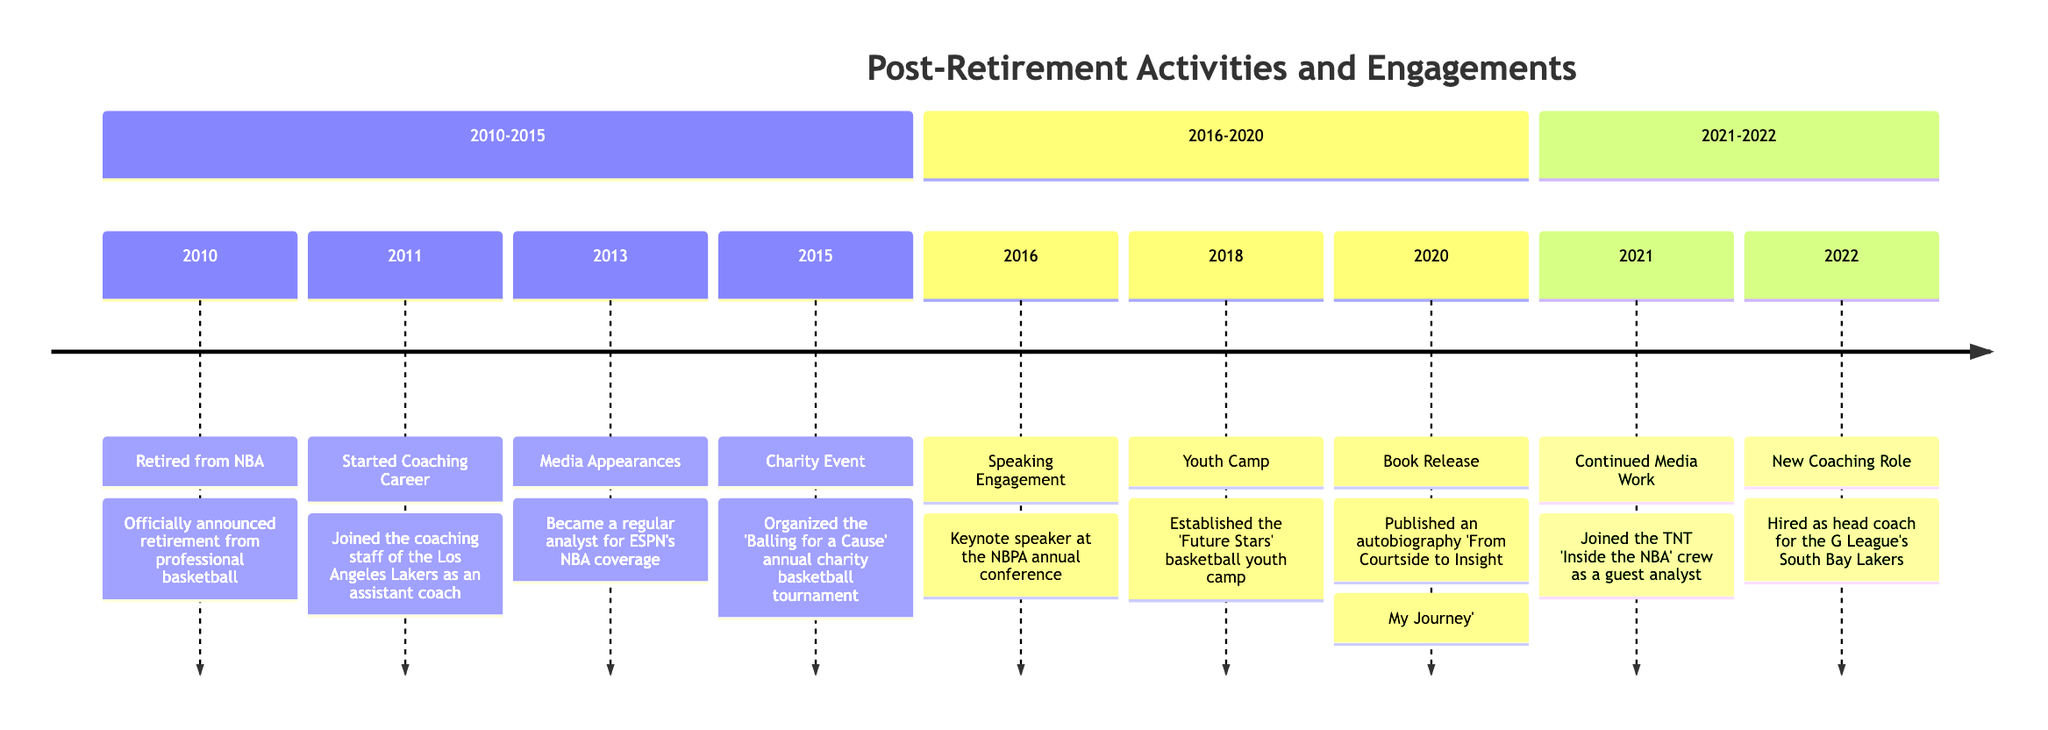What year did you retire from the NBA? The timeline starts with the event "Retired from NBA," which clearly indicates the year as 2010.
Answer: 2010 Which organization did you join as an assistant coach in 2011? The activity for 2011 is "Started Coaching Career" and mentions that you joined the coaching staff of the Los Angeles Lakers.
Answer: Los Angeles Lakers In what year did you become a regular analyst for ESPN? The timeline specifies "Media Appearances" as an activity in 2013, indicating the year when you became a regular analyst for ESPN.
Answer: 2013 How many years were there between your retirement and your first charity event? The timeline shows that your retirement was in 2010 and the first charity event occurred in 2015. The difference between these two years is 5.
Answer: 5 What was the title of your autobiography released in 2020? The 2020 entry on the timeline includes "Book Release" with the description of publishing an autobiography. The title mentioned is "From Courtside to Insight: My Journey."
Answer: From Courtside to Insight: My Journey What activity occurred right after you organized the charity basketball tournament? Following the charity event in 2015, the next activity listed in the timeline is "Speaking Engagement" in 2016. This indicates the order of events post-charity event.
Answer: Speaking Engagement Which position did you take on the G League's South Bay Lakers in 2022? The timeline details that in 2022, the activity noted is "New Coaching Role," stating you were hired as head coach for the G League's South Bay Lakers.
Answer: Head Coach How many total activities are listed on the timeline? Counting the total elements in the timeline, there are 9 distinct activities listed from 2010 to 2022.
Answer: 9 What year did you establish the 'Future Stars' basketball youth camp? According to the timeline, the event titled "Youth Camp" was established in 2018.
Answer: 2018 